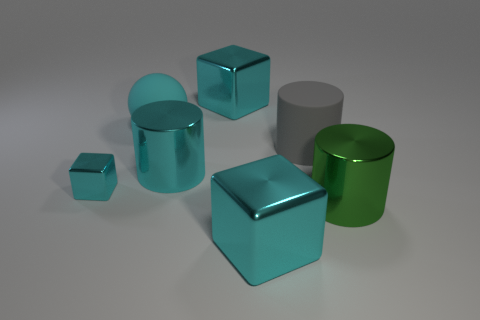Does the cyan metal object that is on the left side of the big matte ball have the same shape as the large shiny thing right of the gray rubber cylinder? no 